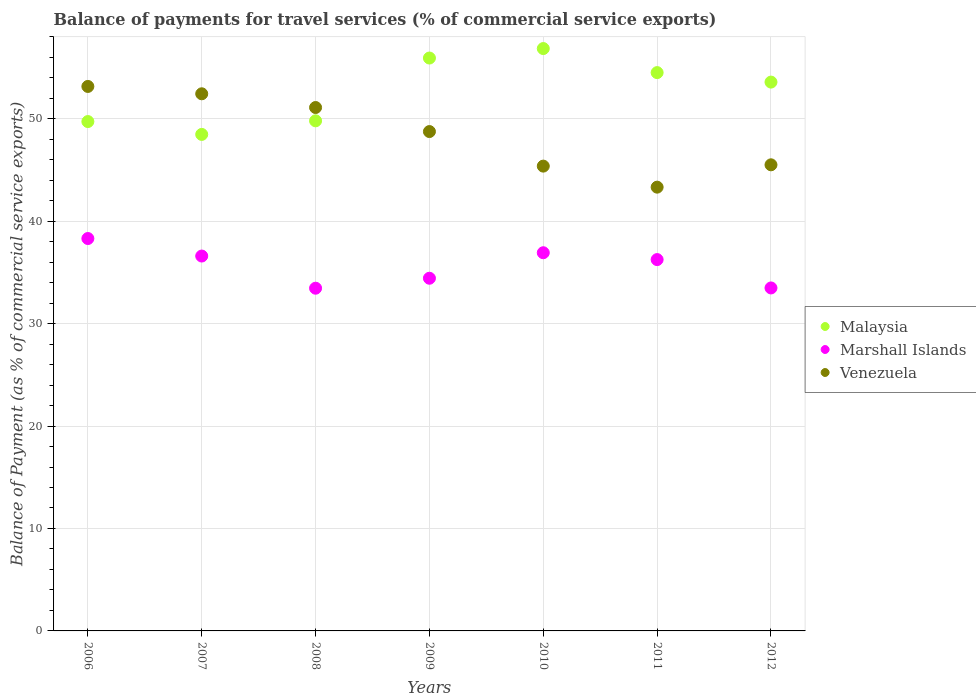How many different coloured dotlines are there?
Provide a succinct answer. 3. Is the number of dotlines equal to the number of legend labels?
Keep it short and to the point. Yes. What is the balance of payments for travel services in Venezuela in 2007?
Your answer should be very brief. 52.43. Across all years, what is the maximum balance of payments for travel services in Marshall Islands?
Your answer should be compact. 38.3. Across all years, what is the minimum balance of payments for travel services in Marshall Islands?
Provide a succinct answer. 33.45. In which year was the balance of payments for travel services in Venezuela minimum?
Give a very brief answer. 2011. What is the total balance of payments for travel services in Marshall Islands in the graph?
Make the answer very short. 249.42. What is the difference between the balance of payments for travel services in Marshall Islands in 2006 and that in 2011?
Offer a terse response. 2.06. What is the difference between the balance of payments for travel services in Malaysia in 2006 and the balance of payments for travel services in Venezuela in 2007?
Keep it short and to the point. -2.71. What is the average balance of payments for travel services in Venezuela per year?
Make the answer very short. 48.51. In the year 2008, what is the difference between the balance of payments for travel services in Venezuela and balance of payments for travel services in Malaysia?
Offer a terse response. 1.3. In how many years, is the balance of payments for travel services in Malaysia greater than 34 %?
Your answer should be very brief. 7. What is the ratio of the balance of payments for travel services in Malaysia in 2008 to that in 2011?
Ensure brevity in your answer.  0.91. Is the balance of payments for travel services in Venezuela in 2008 less than that in 2012?
Give a very brief answer. No. Is the difference between the balance of payments for travel services in Venezuela in 2007 and 2012 greater than the difference between the balance of payments for travel services in Malaysia in 2007 and 2012?
Offer a terse response. Yes. What is the difference between the highest and the second highest balance of payments for travel services in Malaysia?
Provide a succinct answer. 0.93. What is the difference between the highest and the lowest balance of payments for travel services in Malaysia?
Your response must be concise. 8.38. Is the sum of the balance of payments for travel services in Venezuela in 2006 and 2011 greater than the maximum balance of payments for travel services in Malaysia across all years?
Offer a terse response. Yes. Does the balance of payments for travel services in Marshall Islands monotonically increase over the years?
Your answer should be very brief. No. How many years are there in the graph?
Your response must be concise. 7. What is the difference between two consecutive major ticks on the Y-axis?
Offer a very short reply. 10. Does the graph contain any zero values?
Ensure brevity in your answer.  No. Does the graph contain grids?
Make the answer very short. Yes. Where does the legend appear in the graph?
Give a very brief answer. Center right. What is the title of the graph?
Ensure brevity in your answer.  Balance of payments for travel services (% of commercial service exports). Does "St. Vincent and the Grenadines" appear as one of the legend labels in the graph?
Your answer should be compact. No. What is the label or title of the X-axis?
Make the answer very short. Years. What is the label or title of the Y-axis?
Ensure brevity in your answer.  Balance of Payment (as % of commercial service exports). What is the Balance of Payment (as % of commercial service exports) in Malaysia in 2006?
Provide a short and direct response. 49.72. What is the Balance of Payment (as % of commercial service exports) of Marshall Islands in 2006?
Provide a succinct answer. 38.3. What is the Balance of Payment (as % of commercial service exports) in Venezuela in 2006?
Offer a terse response. 53.15. What is the Balance of Payment (as % of commercial service exports) in Malaysia in 2007?
Ensure brevity in your answer.  48.47. What is the Balance of Payment (as % of commercial service exports) of Marshall Islands in 2007?
Your response must be concise. 36.59. What is the Balance of Payment (as % of commercial service exports) in Venezuela in 2007?
Offer a very short reply. 52.43. What is the Balance of Payment (as % of commercial service exports) in Malaysia in 2008?
Give a very brief answer. 49.79. What is the Balance of Payment (as % of commercial service exports) of Marshall Islands in 2008?
Keep it short and to the point. 33.45. What is the Balance of Payment (as % of commercial service exports) in Venezuela in 2008?
Your answer should be compact. 51.09. What is the Balance of Payment (as % of commercial service exports) of Malaysia in 2009?
Your answer should be very brief. 55.92. What is the Balance of Payment (as % of commercial service exports) in Marshall Islands in 2009?
Provide a succinct answer. 34.43. What is the Balance of Payment (as % of commercial service exports) of Venezuela in 2009?
Provide a succinct answer. 48.74. What is the Balance of Payment (as % of commercial service exports) in Malaysia in 2010?
Give a very brief answer. 56.85. What is the Balance of Payment (as % of commercial service exports) of Marshall Islands in 2010?
Your answer should be compact. 36.92. What is the Balance of Payment (as % of commercial service exports) in Venezuela in 2010?
Offer a very short reply. 45.37. What is the Balance of Payment (as % of commercial service exports) of Malaysia in 2011?
Offer a very short reply. 54.5. What is the Balance of Payment (as % of commercial service exports) of Marshall Islands in 2011?
Keep it short and to the point. 36.25. What is the Balance of Payment (as % of commercial service exports) in Venezuela in 2011?
Your answer should be compact. 43.32. What is the Balance of Payment (as % of commercial service exports) in Malaysia in 2012?
Keep it short and to the point. 53.57. What is the Balance of Payment (as % of commercial service exports) in Marshall Islands in 2012?
Keep it short and to the point. 33.48. What is the Balance of Payment (as % of commercial service exports) of Venezuela in 2012?
Offer a terse response. 45.5. Across all years, what is the maximum Balance of Payment (as % of commercial service exports) in Malaysia?
Make the answer very short. 56.85. Across all years, what is the maximum Balance of Payment (as % of commercial service exports) of Marshall Islands?
Your response must be concise. 38.3. Across all years, what is the maximum Balance of Payment (as % of commercial service exports) in Venezuela?
Offer a terse response. 53.15. Across all years, what is the minimum Balance of Payment (as % of commercial service exports) of Malaysia?
Your answer should be compact. 48.47. Across all years, what is the minimum Balance of Payment (as % of commercial service exports) of Marshall Islands?
Your answer should be very brief. 33.45. Across all years, what is the minimum Balance of Payment (as % of commercial service exports) in Venezuela?
Keep it short and to the point. 43.32. What is the total Balance of Payment (as % of commercial service exports) of Malaysia in the graph?
Give a very brief answer. 368.82. What is the total Balance of Payment (as % of commercial service exports) of Marshall Islands in the graph?
Give a very brief answer. 249.42. What is the total Balance of Payment (as % of commercial service exports) in Venezuela in the graph?
Make the answer very short. 339.6. What is the difference between the Balance of Payment (as % of commercial service exports) of Malaysia in 2006 and that in 2007?
Your answer should be very brief. 1.25. What is the difference between the Balance of Payment (as % of commercial service exports) in Marshall Islands in 2006 and that in 2007?
Give a very brief answer. 1.71. What is the difference between the Balance of Payment (as % of commercial service exports) of Venezuela in 2006 and that in 2007?
Your response must be concise. 0.72. What is the difference between the Balance of Payment (as % of commercial service exports) of Malaysia in 2006 and that in 2008?
Make the answer very short. -0.07. What is the difference between the Balance of Payment (as % of commercial service exports) of Marshall Islands in 2006 and that in 2008?
Provide a short and direct response. 4.85. What is the difference between the Balance of Payment (as % of commercial service exports) in Venezuela in 2006 and that in 2008?
Keep it short and to the point. 2.06. What is the difference between the Balance of Payment (as % of commercial service exports) in Malaysia in 2006 and that in 2009?
Make the answer very short. -6.2. What is the difference between the Balance of Payment (as % of commercial service exports) in Marshall Islands in 2006 and that in 2009?
Offer a terse response. 3.88. What is the difference between the Balance of Payment (as % of commercial service exports) in Venezuela in 2006 and that in 2009?
Your answer should be very brief. 4.4. What is the difference between the Balance of Payment (as % of commercial service exports) in Malaysia in 2006 and that in 2010?
Keep it short and to the point. -7.13. What is the difference between the Balance of Payment (as % of commercial service exports) in Marshall Islands in 2006 and that in 2010?
Your answer should be very brief. 1.39. What is the difference between the Balance of Payment (as % of commercial service exports) of Venezuela in 2006 and that in 2010?
Make the answer very short. 7.78. What is the difference between the Balance of Payment (as % of commercial service exports) of Malaysia in 2006 and that in 2011?
Offer a terse response. -4.78. What is the difference between the Balance of Payment (as % of commercial service exports) in Marshall Islands in 2006 and that in 2011?
Make the answer very short. 2.06. What is the difference between the Balance of Payment (as % of commercial service exports) in Venezuela in 2006 and that in 2011?
Your answer should be compact. 9.83. What is the difference between the Balance of Payment (as % of commercial service exports) of Malaysia in 2006 and that in 2012?
Offer a terse response. -3.85. What is the difference between the Balance of Payment (as % of commercial service exports) in Marshall Islands in 2006 and that in 2012?
Ensure brevity in your answer.  4.82. What is the difference between the Balance of Payment (as % of commercial service exports) of Venezuela in 2006 and that in 2012?
Your response must be concise. 7.65. What is the difference between the Balance of Payment (as % of commercial service exports) of Malaysia in 2007 and that in 2008?
Your answer should be very brief. -1.33. What is the difference between the Balance of Payment (as % of commercial service exports) in Marshall Islands in 2007 and that in 2008?
Your answer should be very brief. 3.14. What is the difference between the Balance of Payment (as % of commercial service exports) of Venezuela in 2007 and that in 2008?
Offer a terse response. 1.34. What is the difference between the Balance of Payment (as % of commercial service exports) in Malaysia in 2007 and that in 2009?
Your response must be concise. -7.46. What is the difference between the Balance of Payment (as % of commercial service exports) of Marshall Islands in 2007 and that in 2009?
Your answer should be very brief. 2.17. What is the difference between the Balance of Payment (as % of commercial service exports) of Venezuela in 2007 and that in 2009?
Offer a very short reply. 3.69. What is the difference between the Balance of Payment (as % of commercial service exports) in Malaysia in 2007 and that in 2010?
Ensure brevity in your answer.  -8.38. What is the difference between the Balance of Payment (as % of commercial service exports) of Marshall Islands in 2007 and that in 2010?
Your answer should be very brief. -0.32. What is the difference between the Balance of Payment (as % of commercial service exports) in Venezuela in 2007 and that in 2010?
Your response must be concise. 7.06. What is the difference between the Balance of Payment (as % of commercial service exports) of Malaysia in 2007 and that in 2011?
Make the answer very short. -6.03. What is the difference between the Balance of Payment (as % of commercial service exports) of Marshall Islands in 2007 and that in 2011?
Make the answer very short. 0.35. What is the difference between the Balance of Payment (as % of commercial service exports) of Venezuela in 2007 and that in 2011?
Your response must be concise. 9.11. What is the difference between the Balance of Payment (as % of commercial service exports) of Malaysia in 2007 and that in 2012?
Offer a terse response. -5.11. What is the difference between the Balance of Payment (as % of commercial service exports) in Marshall Islands in 2007 and that in 2012?
Ensure brevity in your answer.  3.11. What is the difference between the Balance of Payment (as % of commercial service exports) of Venezuela in 2007 and that in 2012?
Keep it short and to the point. 6.93. What is the difference between the Balance of Payment (as % of commercial service exports) in Malaysia in 2008 and that in 2009?
Keep it short and to the point. -6.13. What is the difference between the Balance of Payment (as % of commercial service exports) of Marshall Islands in 2008 and that in 2009?
Provide a succinct answer. -0.97. What is the difference between the Balance of Payment (as % of commercial service exports) of Venezuela in 2008 and that in 2009?
Your answer should be very brief. 2.35. What is the difference between the Balance of Payment (as % of commercial service exports) of Malaysia in 2008 and that in 2010?
Keep it short and to the point. -7.05. What is the difference between the Balance of Payment (as % of commercial service exports) in Marshall Islands in 2008 and that in 2010?
Make the answer very short. -3.46. What is the difference between the Balance of Payment (as % of commercial service exports) of Venezuela in 2008 and that in 2010?
Give a very brief answer. 5.72. What is the difference between the Balance of Payment (as % of commercial service exports) of Malaysia in 2008 and that in 2011?
Your response must be concise. -4.71. What is the difference between the Balance of Payment (as % of commercial service exports) in Marshall Islands in 2008 and that in 2011?
Ensure brevity in your answer.  -2.79. What is the difference between the Balance of Payment (as % of commercial service exports) of Venezuela in 2008 and that in 2011?
Your response must be concise. 7.77. What is the difference between the Balance of Payment (as % of commercial service exports) of Malaysia in 2008 and that in 2012?
Make the answer very short. -3.78. What is the difference between the Balance of Payment (as % of commercial service exports) in Marshall Islands in 2008 and that in 2012?
Make the answer very short. -0.03. What is the difference between the Balance of Payment (as % of commercial service exports) of Venezuela in 2008 and that in 2012?
Your response must be concise. 5.59. What is the difference between the Balance of Payment (as % of commercial service exports) of Malaysia in 2009 and that in 2010?
Your answer should be compact. -0.93. What is the difference between the Balance of Payment (as % of commercial service exports) in Marshall Islands in 2009 and that in 2010?
Make the answer very short. -2.49. What is the difference between the Balance of Payment (as % of commercial service exports) of Venezuela in 2009 and that in 2010?
Your answer should be compact. 3.37. What is the difference between the Balance of Payment (as % of commercial service exports) of Malaysia in 2009 and that in 2011?
Offer a terse response. 1.42. What is the difference between the Balance of Payment (as % of commercial service exports) in Marshall Islands in 2009 and that in 2011?
Your answer should be compact. -1.82. What is the difference between the Balance of Payment (as % of commercial service exports) of Venezuela in 2009 and that in 2011?
Ensure brevity in your answer.  5.43. What is the difference between the Balance of Payment (as % of commercial service exports) of Malaysia in 2009 and that in 2012?
Make the answer very short. 2.35. What is the difference between the Balance of Payment (as % of commercial service exports) of Marshall Islands in 2009 and that in 2012?
Your answer should be very brief. 0.95. What is the difference between the Balance of Payment (as % of commercial service exports) in Venezuela in 2009 and that in 2012?
Offer a terse response. 3.25. What is the difference between the Balance of Payment (as % of commercial service exports) of Malaysia in 2010 and that in 2011?
Provide a succinct answer. 2.35. What is the difference between the Balance of Payment (as % of commercial service exports) in Marshall Islands in 2010 and that in 2011?
Give a very brief answer. 0.67. What is the difference between the Balance of Payment (as % of commercial service exports) of Venezuela in 2010 and that in 2011?
Keep it short and to the point. 2.05. What is the difference between the Balance of Payment (as % of commercial service exports) in Malaysia in 2010 and that in 2012?
Your answer should be compact. 3.27. What is the difference between the Balance of Payment (as % of commercial service exports) in Marshall Islands in 2010 and that in 2012?
Offer a very short reply. 3.44. What is the difference between the Balance of Payment (as % of commercial service exports) in Venezuela in 2010 and that in 2012?
Your answer should be very brief. -0.13. What is the difference between the Balance of Payment (as % of commercial service exports) in Malaysia in 2011 and that in 2012?
Make the answer very short. 0.93. What is the difference between the Balance of Payment (as % of commercial service exports) in Marshall Islands in 2011 and that in 2012?
Provide a succinct answer. 2.77. What is the difference between the Balance of Payment (as % of commercial service exports) in Venezuela in 2011 and that in 2012?
Your response must be concise. -2.18. What is the difference between the Balance of Payment (as % of commercial service exports) of Malaysia in 2006 and the Balance of Payment (as % of commercial service exports) of Marshall Islands in 2007?
Provide a short and direct response. 13.13. What is the difference between the Balance of Payment (as % of commercial service exports) in Malaysia in 2006 and the Balance of Payment (as % of commercial service exports) in Venezuela in 2007?
Your answer should be very brief. -2.71. What is the difference between the Balance of Payment (as % of commercial service exports) of Marshall Islands in 2006 and the Balance of Payment (as % of commercial service exports) of Venezuela in 2007?
Provide a short and direct response. -14.13. What is the difference between the Balance of Payment (as % of commercial service exports) of Malaysia in 2006 and the Balance of Payment (as % of commercial service exports) of Marshall Islands in 2008?
Your response must be concise. 16.27. What is the difference between the Balance of Payment (as % of commercial service exports) of Malaysia in 2006 and the Balance of Payment (as % of commercial service exports) of Venezuela in 2008?
Give a very brief answer. -1.37. What is the difference between the Balance of Payment (as % of commercial service exports) in Marshall Islands in 2006 and the Balance of Payment (as % of commercial service exports) in Venezuela in 2008?
Offer a terse response. -12.79. What is the difference between the Balance of Payment (as % of commercial service exports) of Malaysia in 2006 and the Balance of Payment (as % of commercial service exports) of Marshall Islands in 2009?
Ensure brevity in your answer.  15.29. What is the difference between the Balance of Payment (as % of commercial service exports) in Malaysia in 2006 and the Balance of Payment (as % of commercial service exports) in Venezuela in 2009?
Make the answer very short. 0.98. What is the difference between the Balance of Payment (as % of commercial service exports) of Marshall Islands in 2006 and the Balance of Payment (as % of commercial service exports) of Venezuela in 2009?
Provide a succinct answer. -10.44. What is the difference between the Balance of Payment (as % of commercial service exports) in Malaysia in 2006 and the Balance of Payment (as % of commercial service exports) in Marshall Islands in 2010?
Your answer should be very brief. 12.8. What is the difference between the Balance of Payment (as % of commercial service exports) in Malaysia in 2006 and the Balance of Payment (as % of commercial service exports) in Venezuela in 2010?
Give a very brief answer. 4.35. What is the difference between the Balance of Payment (as % of commercial service exports) in Marshall Islands in 2006 and the Balance of Payment (as % of commercial service exports) in Venezuela in 2010?
Keep it short and to the point. -7.07. What is the difference between the Balance of Payment (as % of commercial service exports) of Malaysia in 2006 and the Balance of Payment (as % of commercial service exports) of Marshall Islands in 2011?
Offer a very short reply. 13.47. What is the difference between the Balance of Payment (as % of commercial service exports) in Malaysia in 2006 and the Balance of Payment (as % of commercial service exports) in Venezuela in 2011?
Your response must be concise. 6.4. What is the difference between the Balance of Payment (as % of commercial service exports) of Marshall Islands in 2006 and the Balance of Payment (as % of commercial service exports) of Venezuela in 2011?
Offer a very short reply. -5.01. What is the difference between the Balance of Payment (as % of commercial service exports) in Malaysia in 2006 and the Balance of Payment (as % of commercial service exports) in Marshall Islands in 2012?
Provide a succinct answer. 16.24. What is the difference between the Balance of Payment (as % of commercial service exports) in Malaysia in 2006 and the Balance of Payment (as % of commercial service exports) in Venezuela in 2012?
Ensure brevity in your answer.  4.22. What is the difference between the Balance of Payment (as % of commercial service exports) in Marshall Islands in 2006 and the Balance of Payment (as % of commercial service exports) in Venezuela in 2012?
Provide a succinct answer. -7.19. What is the difference between the Balance of Payment (as % of commercial service exports) in Malaysia in 2007 and the Balance of Payment (as % of commercial service exports) in Marshall Islands in 2008?
Provide a short and direct response. 15.01. What is the difference between the Balance of Payment (as % of commercial service exports) in Malaysia in 2007 and the Balance of Payment (as % of commercial service exports) in Venezuela in 2008?
Provide a succinct answer. -2.62. What is the difference between the Balance of Payment (as % of commercial service exports) of Marshall Islands in 2007 and the Balance of Payment (as % of commercial service exports) of Venezuela in 2008?
Your answer should be compact. -14.5. What is the difference between the Balance of Payment (as % of commercial service exports) of Malaysia in 2007 and the Balance of Payment (as % of commercial service exports) of Marshall Islands in 2009?
Keep it short and to the point. 14.04. What is the difference between the Balance of Payment (as % of commercial service exports) in Malaysia in 2007 and the Balance of Payment (as % of commercial service exports) in Venezuela in 2009?
Give a very brief answer. -0.28. What is the difference between the Balance of Payment (as % of commercial service exports) of Marshall Islands in 2007 and the Balance of Payment (as % of commercial service exports) of Venezuela in 2009?
Your answer should be compact. -12.15. What is the difference between the Balance of Payment (as % of commercial service exports) in Malaysia in 2007 and the Balance of Payment (as % of commercial service exports) in Marshall Islands in 2010?
Your answer should be compact. 11.55. What is the difference between the Balance of Payment (as % of commercial service exports) in Malaysia in 2007 and the Balance of Payment (as % of commercial service exports) in Venezuela in 2010?
Your answer should be compact. 3.1. What is the difference between the Balance of Payment (as % of commercial service exports) of Marshall Islands in 2007 and the Balance of Payment (as % of commercial service exports) of Venezuela in 2010?
Provide a succinct answer. -8.78. What is the difference between the Balance of Payment (as % of commercial service exports) in Malaysia in 2007 and the Balance of Payment (as % of commercial service exports) in Marshall Islands in 2011?
Provide a short and direct response. 12.22. What is the difference between the Balance of Payment (as % of commercial service exports) of Malaysia in 2007 and the Balance of Payment (as % of commercial service exports) of Venezuela in 2011?
Give a very brief answer. 5.15. What is the difference between the Balance of Payment (as % of commercial service exports) in Marshall Islands in 2007 and the Balance of Payment (as % of commercial service exports) in Venezuela in 2011?
Provide a short and direct response. -6.72. What is the difference between the Balance of Payment (as % of commercial service exports) of Malaysia in 2007 and the Balance of Payment (as % of commercial service exports) of Marshall Islands in 2012?
Your response must be concise. 14.99. What is the difference between the Balance of Payment (as % of commercial service exports) of Malaysia in 2007 and the Balance of Payment (as % of commercial service exports) of Venezuela in 2012?
Offer a terse response. 2.97. What is the difference between the Balance of Payment (as % of commercial service exports) in Marshall Islands in 2007 and the Balance of Payment (as % of commercial service exports) in Venezuela in 2012?
Provide a succinct answer. -8.91. What is the difference between the Balance of Payment (as % of commercial service exports) in Malaysia in 2008 and the Balance of Payment (as % of commercial service exports) in Marshall Islands in 2009?
Ensure brevity in your answer.  15.37. What is the difference between the Balance of Payment (as % of commercial service exports) in Malaysia in 2008 and the Balance of Payment (as % of commercial service exports) in Venezuela in 2009?
Your response must be concise. 1.05. What is the difference between the Balance of Payment (as % of commercial service exports) of Marshall Islands in 2008 and the Balance of Payment (as % of commercial service exports) of Venezuela in 2009?
Ensure brevity in your answer.  -15.29. What is the difference between the Balance of Payment (as % of commercial service exports) of Malaysia in 2008 and the Balance of Payment (as % of commercial service exports) of Marshall Islands in 2010?
Keep it short and to the point. 12.88. What is the difference between the Balance of Payment (as % of commercial service exports) in Malaysia in 2008 and the Balance of Payment (as % of commercial service exports) in Venezuela in 2010?
Ensure brevity in your answer.  4.42. What is the difference between the Balance of Payment (as % of commercial service exports) in Marshall Islands in 2008 and the Balance of Payment (as % of commercial service exports) in Venezuela in 2010?
Your answer should be compact. -11.92. What is the difference between the Balance of Payment (as % of commercial service exports) of Malaysia in 2008 and the Balance of Payment (as % of commercial service exports) of Marshall Islands in 2011?
Keep it short and to the point. 13.55. What is the difference between the Balance of Payment (as % of commercial service exports) of Malaysia in 2008 and the Balance of Payment (as % of commercial service exports) of Venezuela in 2011?
Give a very brief answer. 6.48. What is the difference between the Balance of Payment (as % of commercial service exports) in Marshall Islands in 2008 and the Balance of Payment (as % of commercial service exports) in Venezuela in 2011?
Your answer should be very brief. -9.86. What is the difference between the Balance of Payment (as % of commercial service exports) of Malaysia in 2008 and the Balance of Payment (as % of commercial service exports) of Marshall Islands in 2012?
Offer a very short reply. 16.31. What is the difference between the Balance of Payment (as % of commercial service exports) of Malaysia in 2008 and the Balance of Payment (as % of commercial service exports) of Venezuela in 2012?
Your answer should be very brief. 4.29. What is the difference between the Balance of Payment (as % of commercial service exports) of Marshall Islands in 2008 and the Balance of Payment (as % of commercial service exports) of Venezuela in 2012?
Make the answer very short. -12.05. What is the difference between the Balance of Payment (as % of commercial service exports) in Malaysia in 2009 and the Balance of Payment (as % of commercial service exports) in Marshall Islands in 2010?
Offer a very short reply. 19.01. What is the difference between the Balance of Payment (as % of commercial service exports) in Malaysia in 2009 and the Balance of Payment (as % of commercial service exports) in Venezuela in 2010?
Offer a terse response. 10.55. What is the difference between the Balance of Payment (as % of commercial service exports) in Marshall Islands in 2009 and the Balance of Payment (as % of commercial service exports) in Venezuela in 2010?
Ensure brevity in your answer.  -10.94. What is the difference between the Balance of Payment (as % of commercial service exports) of Malaysia in 2009 and the Balance of Payment (as % of commercial service exports) of Marshall Islands in 2011?
Your answer should be very brief. 19.67. What is the difference between the Balance of Payment (as % of commercial service exports) in Malaysia in 2009 and the Balance of Payment (as % of commercial service exports) in Venezuela in 2011?
Provide a succinct answer. 12.6. What is the difference between the Balance of Payment (as % of commercial service exports) in Marshall Islands in 2009 and the Balance of Payment (as % of commercial service exports) in Venezuela in 2011?
Your answer should be very brief. -8.89. What is the difference between the Balance of Payment (as % of commercial service exports) in Malaysia in 2009 and the Balance of Payment (as % of commercial service exports) in Marshall Islands in 2012?
Make the answer very short. 22.44. What is the difference between the Balance of Payment (as % of commercial service exports) of Malaysia in 2009 and the Balance of Payment (as % of commercial service exports) of Venezuela in 2012?
Make the answer very short. 10.42. What is the difference between the Balance of Payment (as % of commercial service exports) in Marshall Islands in 2009 and the Balance of Payment (as % of commercial service exports) in Venezuela in 2012?
Make the answer very short. -11.07. What is the difference between the Balance of Payment (as % of commercial service exports) in Malaysia in 2010 and the Balance of Payment (as % of commercial service exports) in Marshall Islands in 2011?
Your answer should be very brief. 20.6. What is the difference between the Balance of Payment (as % of commercial service exports) of Malaysia in 2010 and the Balance of Payment (as % of commercial service exports) of Venezuela in 2011?
Provide a short and direct response. 13.53. What is the difference between the Balance of Payment (as % of commercial service exports) in Marshall Islands in 2010 and the Balance of Payment (as % of commercial service exports) in Venezuela in 2011?
Provide a succinct answer. -6.4. What is the difference between the Balance of Payment (as % of commercial service exports) in Malaysia in 2010 and the Balance of Payment (as % of commercial service exports) in Marshall Islands in 2012?
Offer a very short reply. 23.37. What is the difference between the Balance of Payment (as % of commercial service exports) in Malaysia in 2010 and the Balance of Payment (as % of commercial service exports) in Venezuela in 2012?
Provide a succinct answer. 11.35. What is the difference between the Balance of Payment (as % of commercial service exports) of Marshall Islands in 2010 and the Balance of Payment (as % of commercial service exports) of Venezuela in 2012?
Keep it short and to the point. -8.58. What is the difference between the Balance of Payment (as % of commercial service exports) in Malaysia in 2011 and the Balance of Payment (as % of commercial service exports) in Marshall Islands in 2012?
Your response must be concise. 21.02. What is the difference between the Balance of Payment (as % of commercial service exports) of Malaysia in 2011 and the Balance of Payment (as % of commercial service exports) of Venezuela in 2012?
Offer a very short reply. 9. What is the difference between the Balance of Payment (as % of commercial service exports) of Marshall Islands in 2011 and the Balance of Payment (as % of commercial service exports) of Venezuela in 2012?
Keep it short and to the point. -9.25. What is the average Balance of Payment (as % of commercial service exports) of Malaysia per year?
Provide a short and direct response. 52.69. What is the average Balance of Payment (as % of commercial service exports) of Marshall Islands per year?
Keep it short and to the point. 35.63. What is the average Balance of Payment (as % of commercial service exports) of Venezuela per year?
Your response must be concise. 48.51. In the year 2006, what is the difference between the Balance of Payment (as % of commercial service exports) of Malaysia and Balance of Payment (as % of commercial service exports) of Marshall Islands?
Your answer should be very brief. 11.42. In the year 2006, what is the difference between the Balance of Payment (as % of commercial service exports) in Malaysia and Balance of Payment (as % of commercial service exports) in Venezuela?
Your answer should be very brief. -3.43. In the year 2006, what is the difference between the Balance of Payment (as % of commercial service exports) of Marshall Islands and Balance of Payment (as % of commercial service exports) of Venezuela?
Ensure brevity in your answer.  -14.85. In the year 2007, what is the difference between the Balance of Payment (as % of commercial service exports) of Malaysia and Balance of Payment (as % of commercial service exports) of Marshall Islands?
Your answer should be very brief. 11.87. In the year 2007, what is the difference between the Balance of Payment (as % of commercial service exports) in Malaysia and Balance of Payment (as % of commercial service exports) in Venezuela?
Your answer should be very brief. -3.96. In the year 2007, what is the difference between the Balance of Payment (as % of commercial service exports) of Marshall Islands and Balance of Payment (as % of commercial service exports) of Venezuela?
Provide a succinct answer. -15.84. In the year 2008, what is the difference between the Balance of Payment (as % of commercial service exports) of Malaysia and Balance of Payment (as % of commercial service exports) of Marshall Islands?
Keep it short and to the point. 16.34. In the year 2008, what is the difference between the Balance of Payment (as % of commercial service exports) of Malaysia and Balance of Payment (as % of commercial service exports) of Venezuela?
Ensure brevity in your answer.  -1.3. In the year 2008, what is the difference between the Balance of Payment (as % of commercial service exports) of Marshall Islands and Balance of Payment (as % of commercial service exports) of Venezuela?
Provide a succinct answer. -17.64. In the year 2009, what is the difference between the Balance of Payment (as % of commercial service exports) in Malaysia and Balance of Payment (as % of commercial service exports) in Marshall Islands?
Your response must be concise. 21.49. In the year 2009, what is the difference between the Balance of Payment (as % of commercial service exports) in Malaysia and Balance of Payment (as % of commercial service exports) in Venezuela?
Your answer should be very brief. 7.18. In the year 2009, what is the difference between the Balance of Payment (as % of commercial service exports) of Marshall Islands and Balance of Payment (as % of commercial service exports) of Venezuela?
Give a very brief answer. -14.32. In the year 2010, what is the difference between the Balance of Payment (as % of commercial service exports) of Malaysia and Balance of Payment (as % of commercial service exports) of Marshall Islands?
Your response must be concise. 19.93. In the year 2010, what is the difference between the Balance of Payment (as % of commercial service exports) of Malaysia and Balance of Payment (as % of commercial service exports) of Venezuela?
Offer a terse response. 11.48. In the year 2010, what is the difference between the Balance of Payment (as % of commercial service exports) of Marshall Islands and Balance of Payment (as % of commercial service exports) of Venezuela?
Keep it short and to the point. -8.45. In the year 2011, what is the difference between the Balance of Payment (as % of commercial service exports) in Malaysia and Balance of Payment (as % of commercial service exports) in Marshall Islands?
Your answer should be compact. 18.25. In the year 2011, what is the difference between the Balance of Payment (as % of commercial service exports) in Malaysia and Balance of Payment (as % of commercial service exports) in Venezuela?
Keep it short and to the point. 11.18. In the year 2011, what is the difference between the Balance of Payment (as % of commercial service exports) of Marshall Islands and Balance of Payment (as % of commercial service exports) of Venezuela?
Your response must be concise. -7.07. In the year 2012, what is the difference between the Balance of Payment (as % of commercial service exports) of Malaysia and Balance of Payment (as % of commercial service exports) of Marshall Islands?
Provide a short and direct response. 20.09. In the year 2012, what is the difference between the Balance of Payment (as % of commercial service exports) of Malaysia and Balance of Payment (as % of commercial service exports) of Venezuela?
Provide a succinct answer. 8.07. In the year 2012, what is the difference between the Balance of Payment (as % of commercial service exports) of Marshall Islands and Balance of Payment (as % of commercial service exports) of Venezuela?
Offer a very short reply. -12.02. What is the ratio of the Balance of Payment (as % of commercial service exports) in Malaysia in 2006 to that in 2007?
Your answer should be compact. 1.03. What is the ratio of the Balance of Payment (as % of commercial service exports) of Marshall Islands in 2006 to that in 2007?
Provide a succinct answer. 1.05. What is the ratio of the Balance of Payment (as % of commercial service exports) in Venezuela in 2006 to that in 2007?
Ensure brevity in your answer.  1.01. What is the ratio of the Balance of Payment (as % of commercial service exports) in Marshall Islands in 2006 to that in 2008?
Keep it short and to the point. 1.15. What is the ratio of the Balance of Payment (as % of commercial service exports) in Venezuela in 2006 to that in 2008?
Provide a short and direct response. 1.04. What is the ratio of the Balance of Payment (as % of commercial service exports) of Malaysia in 2006 to that in 2009?
Make the answer very short. 0.89. What is the ratio of the Balance of Payment (as % of commercial service exports) of Marshall Islands in 2006 to that in 2009?
Keep it short and to the point. 1.11. What is the ratio of the Balance of Payment (as % of commercial service exports) in Venezuela in 2006 to that in 2009?
Your response must be concise. 1.09. What is the ratio of the Balance of Payment (as % of commercial service exports) of Malaysia in 2006 to that in 2010?
Keep it short and to the point. 0.87. What is the ratio of the Balance of Payment (as % of commercial service exports) of Marshall Islands in 2006 to that in 2010?
Your answer should be compact. 1.04. What is the ratio of the Balance of Payment (as % of commercial service exports) in Venezuela in 2006 to that in 2010?
Provide a short and direct response. 1.17. What is the ratio of the Balance of Payment (as % of commercial service exports) in Malaysia in 2006 to that in 2011?
Offer a very short reply. 0.91. What is the ratio of the Balance of Payment (as % of commercial service exports) in Marshall Islands in 2006 to that in 2011?
Provide a succinct answer. 1.06. What is the ratio of the Balance of Payment (as % of commercial service exports) of Venezuela in 2006 to that in 2011?
Make the answer very short. 1.23. What is the ratio of the Balance of Payment (as % of commercial service exports) of Malaysia in 2006 to that in 2012?
Provide a short and direct response. 0.93. What is the ratio of the Balance of Payment (as % of commercial service exports) in Marshall Islands in 2006 to that in 2012?
Your response must be concise. 1.14. What is the ratio of the Balance of Payment (as % of commercial service exports) in Venezuela in 2006 to that in 2012?
Your answer should be very brief. 1.17. What is the ratio of the Balance of Payment (as % of commercial service exports) of Malaysia in 2007 to that in 2008?
Ensure brevity in your answer.  0.97. What is the ratio of the Balance of Payment (as % of commercial service exports) of Marshall Islands in 2007 to that in 2008?
Offer a terse response. 1.09. What is the ratio of the Balance of Payment (as % of commercial service exports) of Venezuela in 2007 to that in 2008?
Keep it short and to the point. 1.03. What is the ratio of the Balance of Payment (as % of commercial service exports) of Malaysia in 2007 to that in 2009?
Give a very brief answer. 0.87. What is the ratio of the Balance of Payment (as % of commercial service exports) in Marshall Islands in 2007 to that in 2009?
Make the answer very short. 1.06. What is the ratio of the Balance of Payment (as % of commercial service exports) in Venezuela in 2007 to that in 2009?
Ensure brevity in your answer.  1.08. What is the ratio of the Balance of Payment (as % of commercial service exports) of Malaysia in 2007 to that in 2010?
Your answer should be very brief. 0.85. What is the ratio of the Balance of Payment (as % of commercial service exports) in Venezuela in 2007 to that in 2010?
Make the answer very short. 1.16. What is the ratio of the Balance of Payment (as % of commercial service exports) of Malaysia in 2007 to that in 2011?
Provide a short and direct response. 0.89. What is the ratio of the Balance of Payment (as % of commercial service exports) in Marshall Islands in 2007 to that in 2011?
Offer a very short reply. 1.01. What is the ratio of the Balance of Payment (as % of commercial service exports) in Venezuela in 2007 to that in 2011?
Make the answer very short. 1.21. What is the ratio of the Balance of Payment (as % of commercial service exports) of Malaysia in 2007 to that in 2012?
Provide a short and direct response. 0.9. What is the ratio of the Balance of Payment (as % of commercial service exports) of Marshall Islands in 2007 to that in 2012?
Your response must be concise. 1.09. What is the ratio of the Balance of Payment (as % of commercial service exports) of Venezuela in 2007 to that in 2012?
Ensure brevity in your answer.  1.15. What is the ratio of the Balance of Payment (as % of commercial service exports) in Malaysia in 2008 to that in 2009?
Your answer should be very brief. 0.89. What is the ratio of the Balance of Payment (as % of commercial service exports) of Marshall Islands in 2008 to that in 2009?
Your answer should be very brief. 0.97. What is the ratio of the Balance of Payment (as % of commercial service exports) in Venezuela in 2008 to that in 2009?
Give a very brief answer. 1.05. What is the ratio of the Balance of Payment (as % of commercial service exports) in Malaysia in 2008 to that in 2010?
Offer a terse response. 0.88. What is the ratio of the Balance of Payment (as % of commercial service exports) in Marshall Islands in 2008 to that in 2010?
Give a very brief answer. 0.91. What is the ratio of the Balance of Payment (as % of commercial service exports) of Venezuela in 2008 to that in 2010?
Keep it short and to the point. 1.13. What is the ratio of the Balance of Payment (as % of commercial service exports) of Malaysia in 2008 to that in 2011?
Offer a very short reply. 0.91. What is the ratio of the Balance of Payment (as % of commercial service exports) of Marshall Islands in 2008 to that in 2011?
Your response must be concise. 0.92. What is the ratio of the Balance of Payment (as % of commercial service exports) of Venezuela in 2008 to that in 2011?
Provide a short and direct response. 1.18. What is the ratio of the Balance of Payment (as % of commercial service exports) in Malaysia in 2008 to that in 2012?
Offer a very short reply. 0.93. What is the ratio of the Balance of Payment (as % of commercial service exports) of Venezuela in 2008 to that in 2012?
Provide a short and direct response. 1.12. What is the ratio of the Balance of Payment (as % of commercial service exports) of Malaysia in 2009 to that in 2010?
Offer a very short reply. 0.98. What is the ratio of the Balance of Payment (as % of commercial service exports) in Marshall Islands in 2009 to that in 2010?
Your answer should be compact. 0.93. What is the ratio of the Balance of Payment (as % of commercial service exports) in Venezuela in 2009 to that in 2010?
Give a very brief answer. 1.07. What is the ratio of the Balance of Payment (as % of commercial service exports) of Malaysia in 2009 to that in 2011?
Your answer should be very brief. 1.03. What is the ratio of the Balance of Payment (as % of commercial service exports) in Marshall Islands in 2009 to that in 2011?
Offer a very short reply. 0.95. What is the ratio of the Balance of Payment (as % of commercial service exports) of Venezuela in 2009 to that in 2011?
Your response must be concise. 1.13. What is the ratio of the Balance of Payment (as % of commercial service exports) in Malaysia in 2009 to that in 2012?
Offer a very short reply. 1.04. What is the ratio of the Balance of Payment (as % of commercial service exports) of Marshall Islands in 2009 to that in 2012?
Keep it short and to the point. 1.03. What is the ratio of the Balance of Payment (as % of commercial service exports) of Venezuela in 2009 to that in 2012?
Make the answer very short. 1.07. What is the ratio of the Balance of Payment (as % of commercial service exports) of Malaysia in 2010 to that in 2011?
Provide a succinct answer. 1.04. What is the ratio of the Balance of Payment (as % of commercial service exports) of Marshall Islands in 2010 to that in 2011?
Your answer should be compact. 1.02. What is the ratio of the Balance of Payment (as % of commercial service exports) of Venezuela in 2010 to that in 2011?
Ensure brevity in your answer.  1.05. What is the ratio of the Balance of Payment (as % of commercial service exports) of Malaysia in 2010 to that in 2012?
Offer a very short reply. 1.06. What is the ratio of the Balance of Payment (as % of commercial service exports) of Marshall Islands in 2010 to that in 2012?
Keep it short and to the point. 1.1. What is the ratio of the Balance of Payment (as % of commercial service exports) of Venezuela in 2010 to that in 2012?
Keep it short and to the point. 1. What is the ratio of the Balance of Payment (as % of commercial service exports) in Malaysia in 2011 to that in 2012?
Your answer should be very brief. 1.02. What is the ratio of the Balance of Payment (as % of commercial service exports) of Marshall Islands in 2011 to that in 2012?
Give a very brief answer. 1.08. What is the ratio of the Balance of Payment (as % of commercial service exports) of Venezuela in 2011 to that in 2012?
Provide a succinct answer. 0.95. What is the difference between the highest and the second highest Balance of Payment (as % of commercial service exports) of Malaysia?
Your response must be concise. 0.93. What is the difference between the highest and the second highest Balance of Payment (as % of commercial service exports) in Marshall Islands?
Offer a terse response. 1.39. What is the difference between the highest and the second highest Balance of Payment (as % of commercial service exports) in Venezuela?
Ensure brevity in your answer.  0.72. What is the difference between the highest and the lowest Balance of Payment (as % of commercial service exports) in Malaysia?
Provide a short and direct response. 8.38. What is the difference between the highest and the lowest Balance of Payment (as % of commercial service exports) in Marshall Islands?
Your response must be concise. 4.85. What is the difference between the highest and the lowest Balance of Payment (as % of commercial service exports) in Venezuela?
Give a very brief answer. 9.83. 